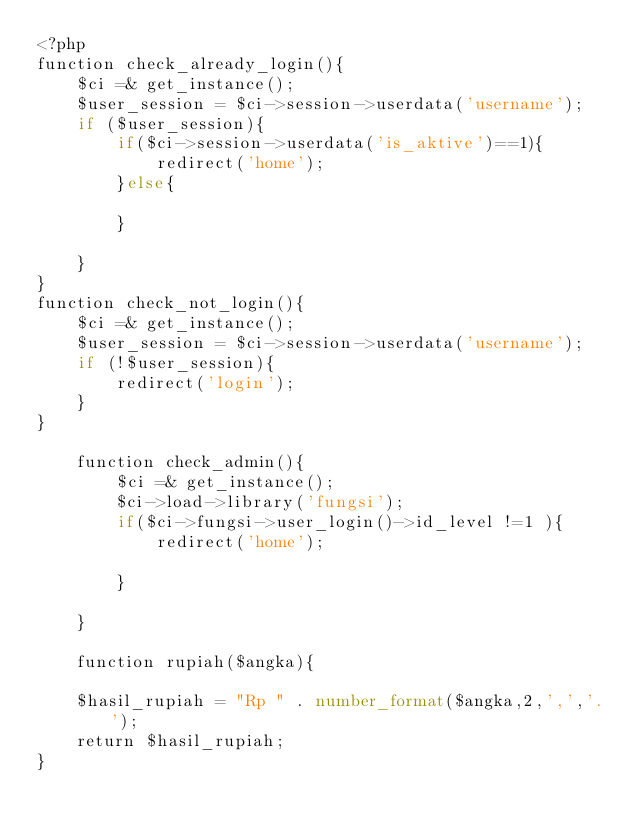Convert code to text. <code><loc_0><loc_0><loc_500><loc_500><_PHP_><?php
function check_already_login(){
    $ci =& get_instance();
    $user_session = $ci->session->userdata('username');
    if ($user_session){
        if($ci->session->userdata('is_aktive')==1){
            redirect('home');
        }else{
            
        }
        
    }
}
function check_not_login(){
    $ci =& get_instance();
    $user_session = $ci->session->userdata('username');
    if (!$user_session){
        redirect('login');
    }
}

    function check_admin(){
        $ci =& get_instance();
        $ci->load->library('fungsi');
        if($ci->fungsi->user_login()->id_level !=1 ){
            redirect('home');

        }

    }

    function rupiah($angka){
    
    $hasil_rupiah = "Rp " . number_format($angka,2,',','.');
    return $hasil_rupiah;
}

    </code> 